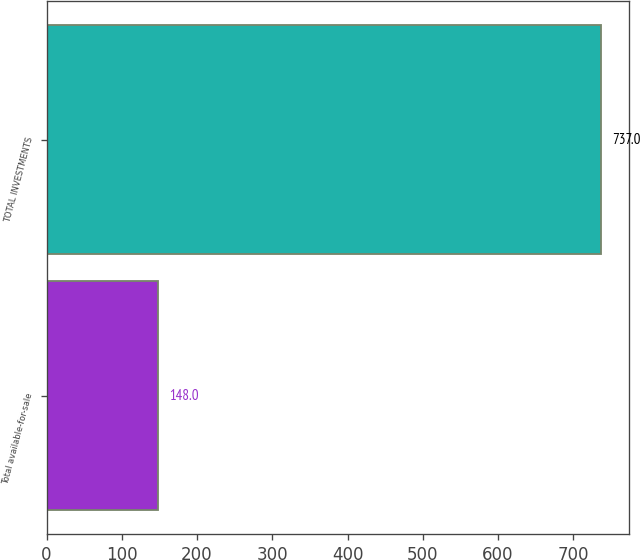<chart> <loc_0><loc_0><loc_500><loc_500><bar_chart><fcel>Total available-for-sale<fcel>TOTAL INVESTMENTS<nl><fcel>148<fcel>737<nl></chart> 